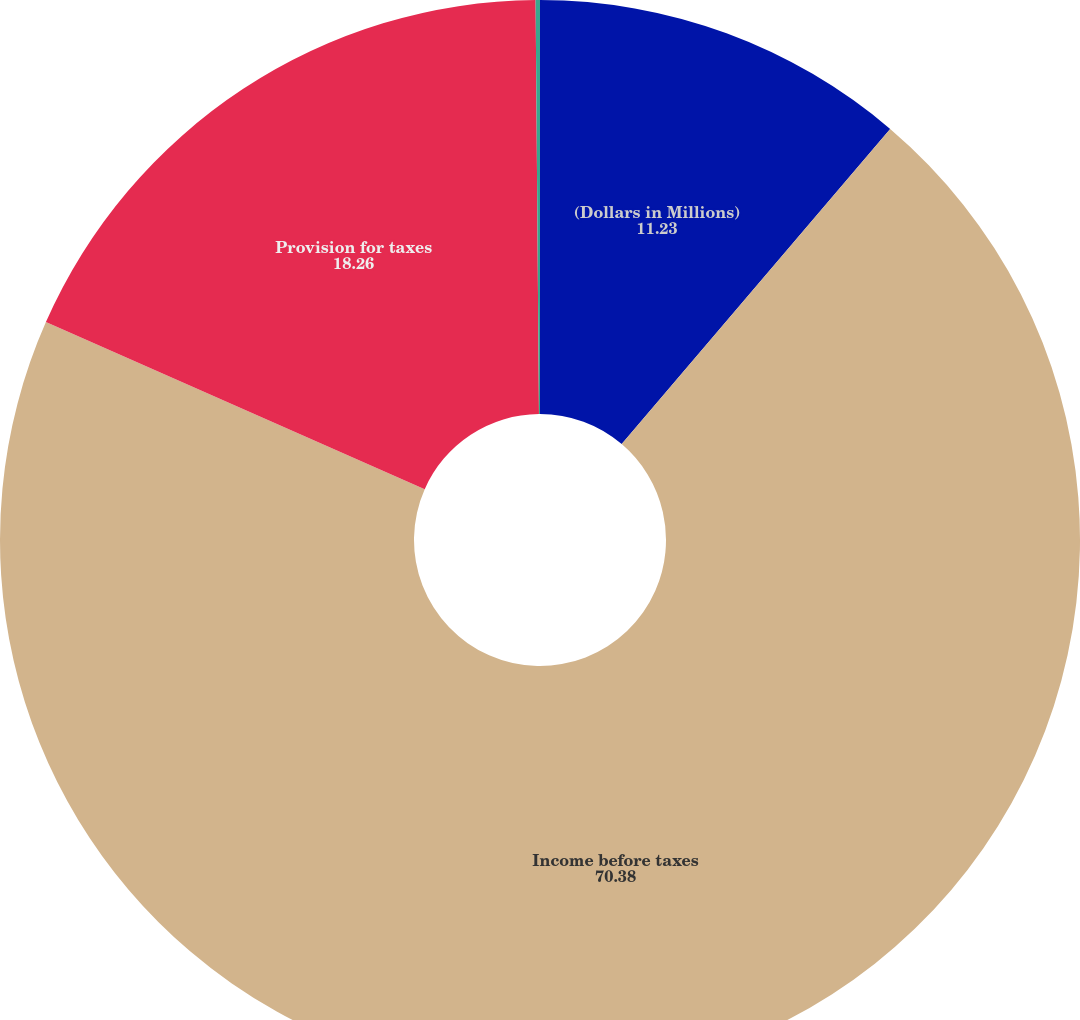<chart> <loc_0><loc_0><loc_500><loc_500><pie_chart><fcel>(Dollars in Millions)<fcel>Income before taxes<fcel>Provision for taxes<fcel>Effective tax rate<nl><fcel>11.23%<fcel>70.38%<fcel>18.26%<fcel>0.13%<nl></chart> 